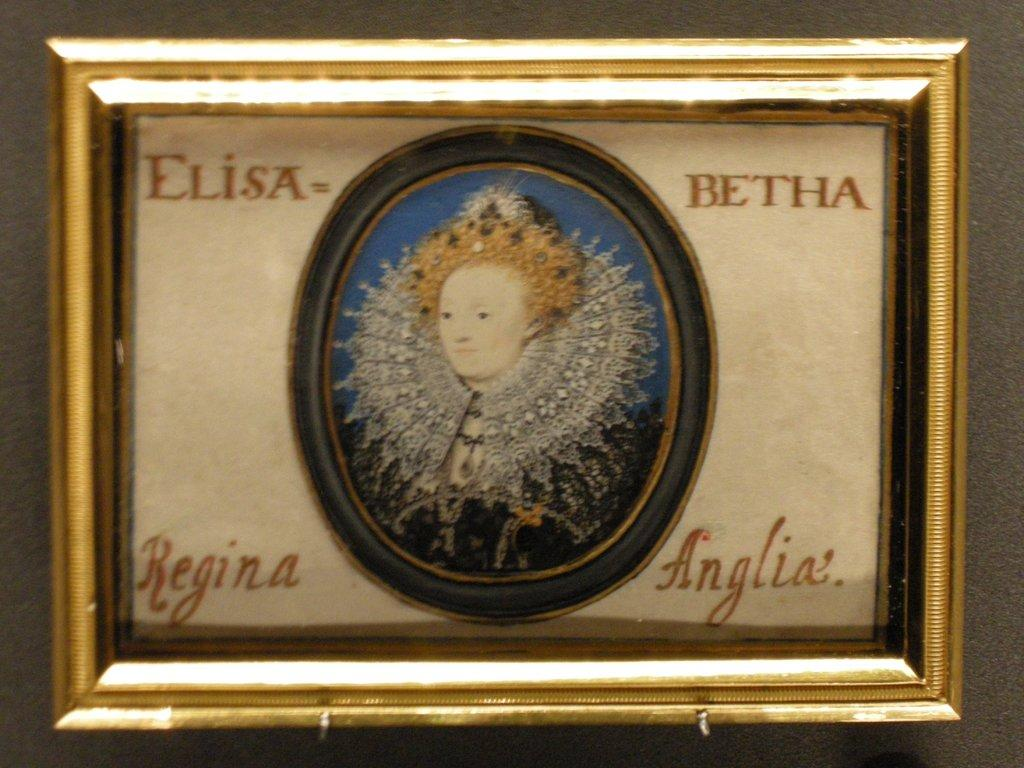What is the main subject of the image? The main subject of the image is a photo frame. What can be seen in the center of the photo frame? In the center of the photo frame, there is a lady. What is the lady thinking about in the image? The image does not provide any information about the lady's thoughts, so we cannot determine what she might be thinking. 